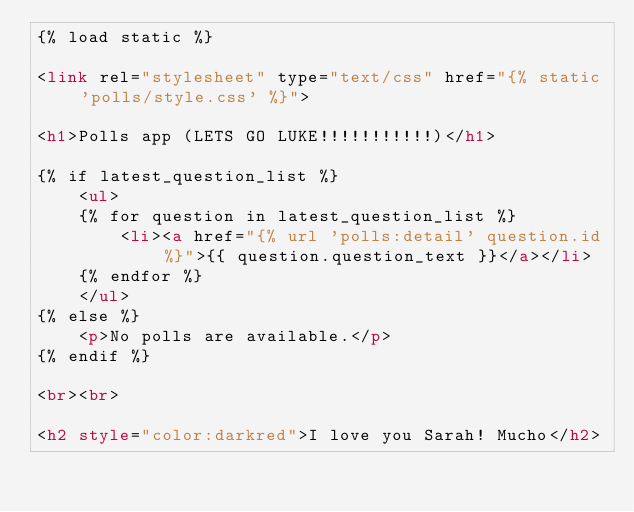<code> <loc_0><loc_0><loc_500><loc_500><_HTML_>{% load static %}

<link rel="stylesheet" type="text/css" href="{% static 'polls/style.css' %}">

<h1>Polls app (LETS GO LUKE!!!!!!!!!!!)</h1>

{% if latest_question_list %}
    <ul>
    {% for question in latest_question_list %}
        <li><a href="{% url 'polls:detail' question.id %}">{{ question.question_text }}</a></li>
    {% endfor %}
    </ul>
{% else %}
    <p>No polls are available.</p>
{% endif %}

<br><br>

<h2 style="color:darkred">I love you Sarah! Mucho</h2></code> 